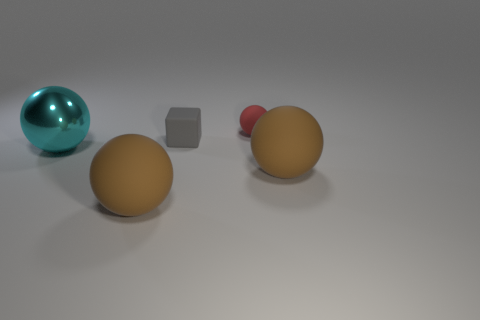There is a object that is both in front of the big cyan metallic thing and left of the gray block; what size is it?
Keep it short and to the point. Large. Is the number of large brown objects in front of the red rubber ball less than the number of gray things?
Keep it short and to the point. No. There is a small thing that is made of the same material as the small gray block; what is its shape?
Provide a short and direct response. Sphere. There is a tiny rubber object left of the small red rubber thing; is its shape the same as the rubber object behind the small matte block?
Your answer should be very brief. No. Are there fewer small gray cubes in front of the cyan shiny sphere than cyan metallic things right of the small gray rubber object?
Offer a terse response. No. What number of brown rubber things are the same size as the gray matte block?
Offer a terse response. 0. Does the ball that is right of the small red rubber object have the same material as the big cyan ball?
Give a very brief answer. No. Is there a ball?
Keep it short and to the point. Yes. The red thing that is the same material as the gray thing is what size?
Your response must be concise. Small. Is there a metal sphere that has the same color as the tiny matte ball?
Keep it short and to the point. No. 